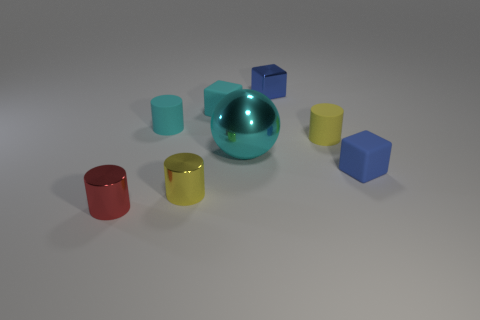How many objects are there in the image, and can you describe their shapes? There are seven objects in the image, including a large cyan sphere, three cylinders with matte finishes in red, yellow, and blue, and three cubes in red, yellow, and blue. These objects are placed on a grey surface with a neutral background. 